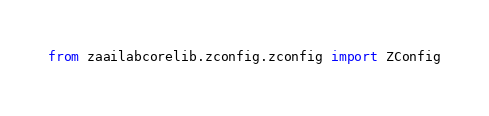Convert code to text. <code><loc_0><loc_0><loc_500><loc_500><_Python_>from zaailabcorelib.zconfig.zconfig import ZConfig</code> 